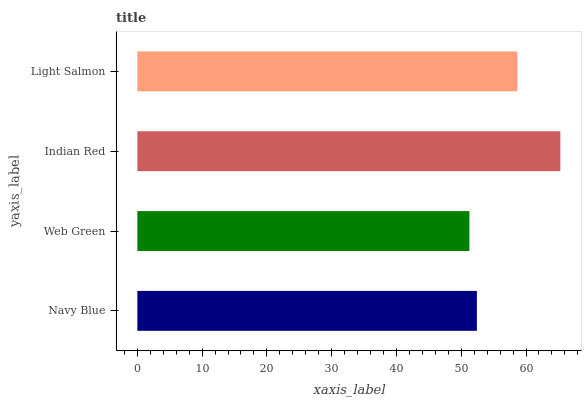Is Web Green the minimum?
Answer yes or no. Yes. Is Indian Red the maximum?
Answer yes or no. Yes. Is Indian Red the minimum?
Answer yes or no. No. Is Web Green the maximum?
Answer yes or no. No. Is Indian Red greater than Web Green?
Answer yes or no. Yes. Is Web Green less than Indian Red?
Answer yes or no. Yes. Is Web Green greater than Indian Red?
Answer yes or no. No. Is Indian Red less than Web Green?
Answer yes or no. No. Is Light Salmon the high median?
Answer yes or no. Yes. Is Navy Blue the low median?
Answer yes or no. Yes. Is Navy Blue the high median?
Answer yes or no. No. Is Web Green the low median?
Answer yes or no. No. 